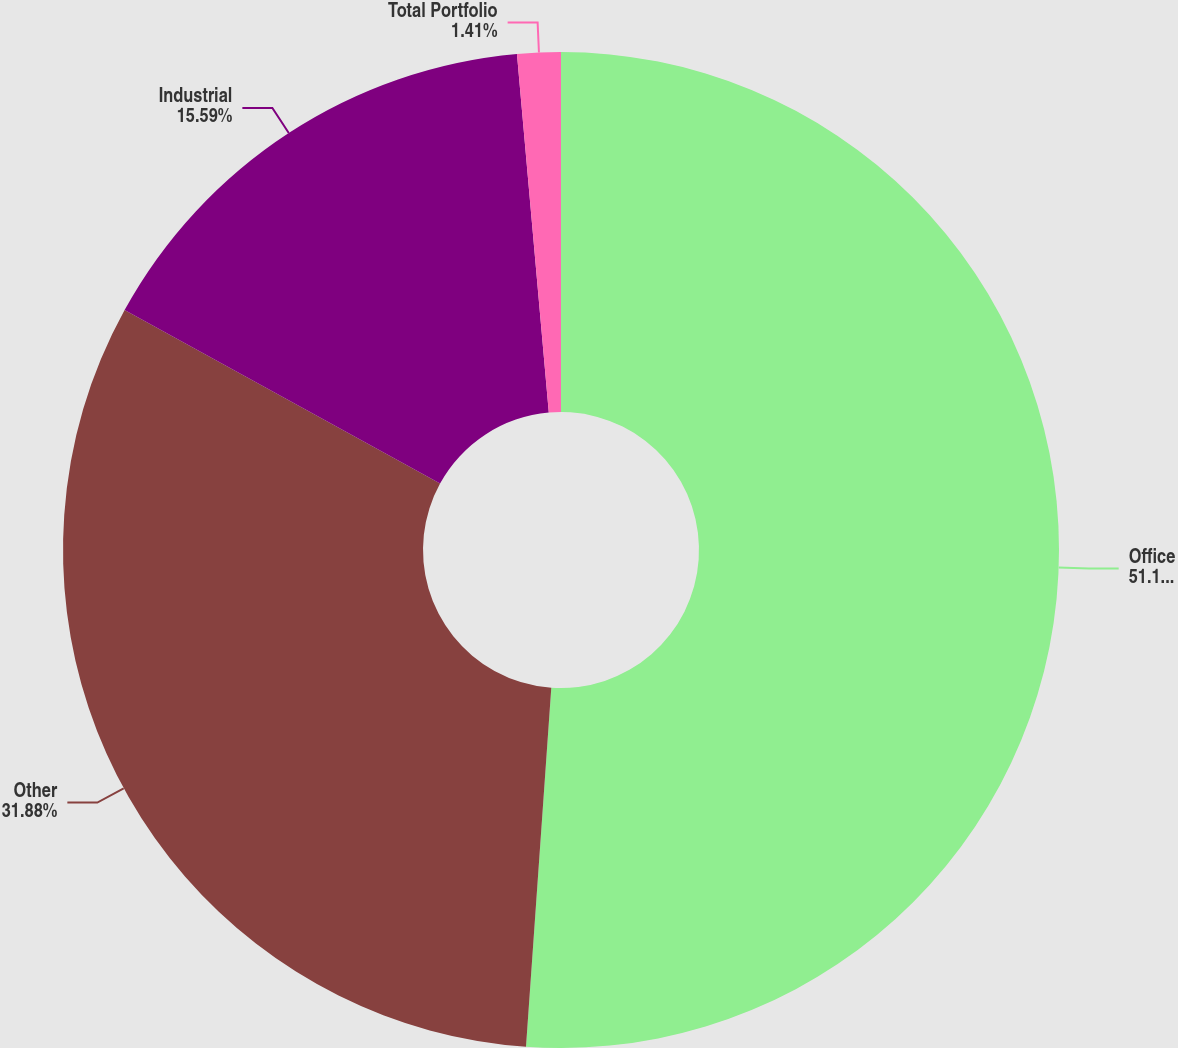Convert chart. <chart><loc_0><loc_0><loc_500><loc_500><pie_chart><fcel>Office<fcel>Other<fcel>Industrial<fcel>Total Portfolio<nl><fcel>51.12%<fcel>31.88%<fcel>15.59%<fcel>1.41%<nl></chart> 